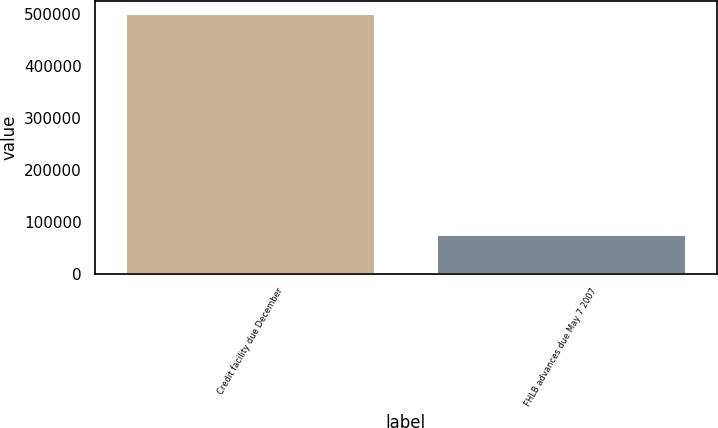Convert chart. <chart><loc_0><loc_0><loc_500><loc_500><bar_chart><fcel>Credit facility due December<fcel>FHLB advances due May 7 2007<nl><fcel>500000<fcel>75000<nl></chart> 